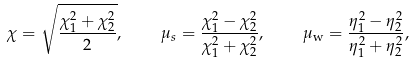Convert formula to latex. <formula><loc_0><loc_0><loc_500><loc_500>\chi = \sqrt { \frac { \chi _ { 1 } ^ { 2 } + \chi _ { 2 } ^ { 2 } } { 2 } } , \quad \mu _ { s } = \frac { \chi _ { 1 } ^ { 2 } - \chi _ { 2 } ^ { 2 } } { \chi _ { 1 } ^ { 2 } + \chi _ { 2 } ^ { 2 } } , \quad \mu _ { \text {w} } = \frac { \eta _ { 1 } ^ { 2 } - \eta _ { 2 } ^ { 2 } } { \eta _ { 1 } ^ { 2 } + \eta _ { 2 } ^ { 2 } } ,</formula> 